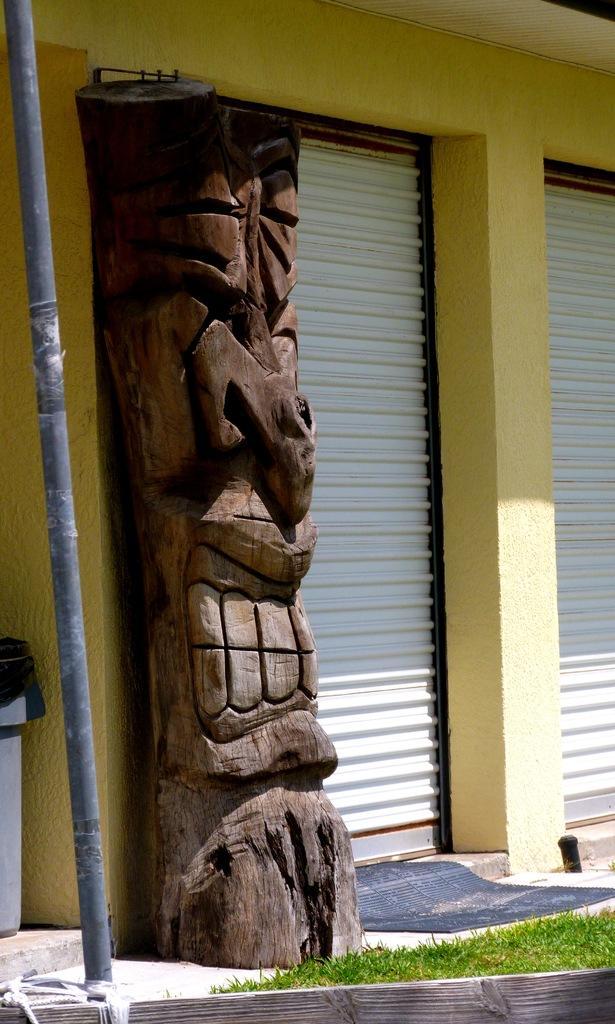Could you give a brief overview of what you see in this image? In this image we can see the wall, shutters, there is a wooden pillar, there is a dustbin, pole, also we can see the grass. 